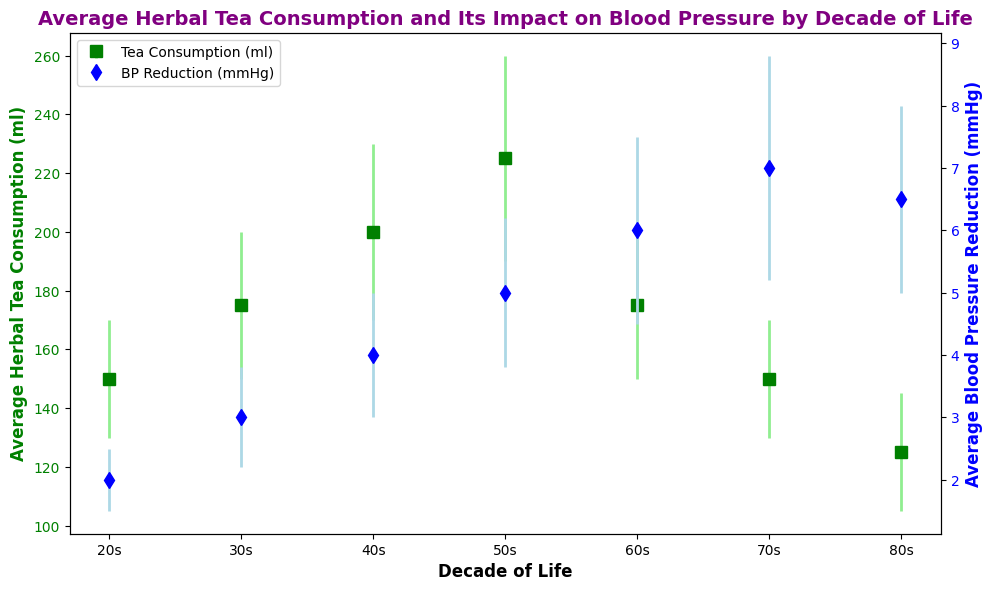What is the average herbal tea consumption in the 40s decade? The chart shows that the average herbal tea consumption for the 40s decade is represented by the green square marker at 200 ml.
Answer: 200 ml Which decade has the highest average blood pressure reduction? The chart shows that the highest point in the blue diamond markers, which represents average blood pressure reduction, is in the 70s decade at 7 mmHg.
Answer: 70s How does the average herbal tea consumption in the 50s compare to the 60s? The green square marker in the 50s is at 225 ml, while the marker in the 60s is at 175 ml. 225 ml is greater than 175 ml.
Answer: 50s has higher tea consumption What is the difference in average blood pressure reduction between the 70s and 80s? The blue diamond marker for the 70s is at 7 mmHg, and for the 80s, it is at 6.5 mmHg. The difference is 7 - 6.5 = 0.5 mmHg.
Answer: 0.5 mmHg Which decade shows the largest error in average herbal tea consumption? The error bars for each decade can be visually inspected. The largest error bar is seen in the 50s decade, with an error of 35 ml.
Answer: 50s Is the trend of average herbal tea consumption increasing or decreasing as people age? The green line plot shows a general increase in herbal tea consumption from the 20s to the 50s, followed by a decrease past the 60s and 70s.
Answer: Increases then decreases Which decade has the smallest error in average blood pressure reduction? The smallest error bar on the blue diamond markers is visually smallest in the 20s decade with an error of 0.5 mmHg.
Answer: 20s What is the sum of average herbal tea consumption for the 20s and 80s decades? The average tea consumption in the 20s is 150 ml and in the 80s is 125 ml. The sum is 150 + 125 = 275 ml.
Answer: 275 ml Does the average blood pressure reduction increase or decrease from the 20s to the 70s? Observing the blue line plot, the average blood pressure reduction consistently increases from 2 mmHg in the 20s to 7 mmHg in the 70s.
Answer: Increases What is the combined error for average herbal tea consumption and blood pressure reduction in the 30s? The error for herbal tea consumption in the 30s is 25 ml and for blood pressure reduction is 0.8 mmHg. Adding them gives 25 + 0.8 = 25.8 combined units.
Answer: 25.8 combined units 